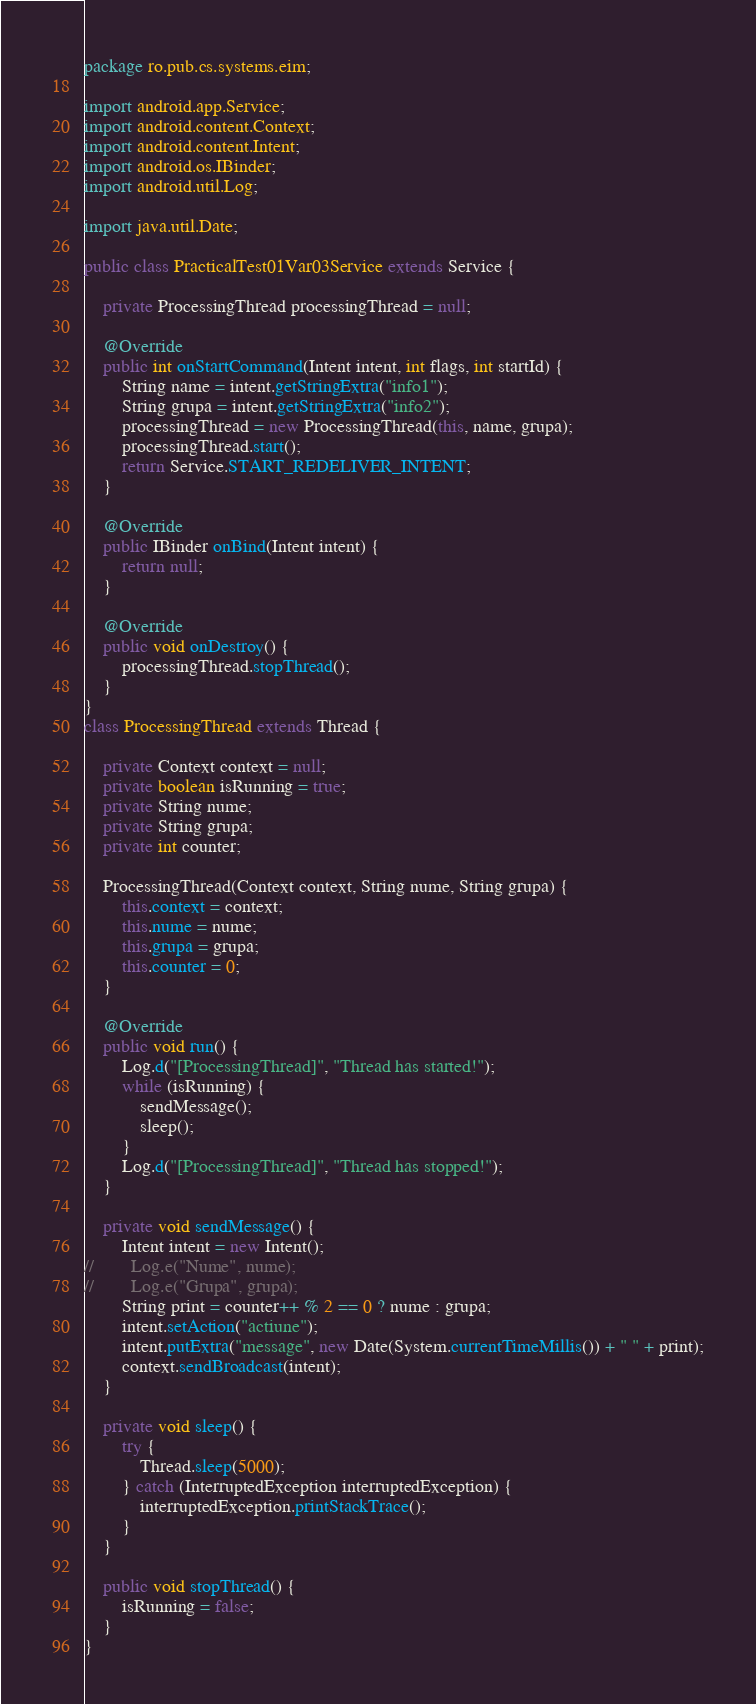<code> <loc_0><loc_0><loc_500><loc_500><_Java_>package ro.pub.cs.systems.eim;

import android.app.Service;
import android.content.Context;
import android.content.Intent;
import android.os.IBinder;
import android.util.Log;

import java.util.Date;

public class PracticalTest01Var03Service extends Service {

    private ProcessingThread processingThread = null;

    @Override
    public int onStartCommand(Intent intent, int flags, int startId) {
        String name = intent.getStringExtra("info1");
        String grupa = intent.getStringExtra("info2");
        processingThread = new ProcessingThread(this, name, grupa);
        processingThread.start();
        return Service.START_REDELIVER_INTENT;
    }

    @Override
    public IBinder onBind(Intent intent) {
        return null;
    }

    @Override
    public void onDestroy() {
        processingThread.stopThread();
    }
}
class ProcessingThread extends Thread {

    private Context context = null;
    private boolean isRunning = true;
    private String nume;
    private String grupa;
    private int counter;

    ProcessingThread(Context context, String nume, String grupa) {
        this.context = context;
        this.nume = nume;
        this.grupa = grupa;
        this.counter = 0;
    }

    @Override
    public void run() {
        Log.d("[ProcessingThread]", "Thread has started!");
        while (isRunning) {
            sendMessage();
            sleep();
        }
        Log.d("[ProcessingThread]", "Thread has stopped!");
    }

    private void sendMessage() {
        Intent intent = new Intent();
//        Log.e("Nume", nume);
//        Log.e("Grupa", grupa);
        String print = counter++ % 2 == 0 ? nume : grupa;
        intent.setAction("actiune");
        intent.putExtra("message", new Date(System.currentTimeMillis()) + " " + print);
        context.sendBroadcast(intent);
    }

    private void sleep() {
        try {
            Thread.sleep(5000);
        } catch (InterruptedException interruptedException) {
            interruptedException.printStackTrace();
        }
    }

    public void stopThread() {
        isRunning = false;
    }
}</code> 